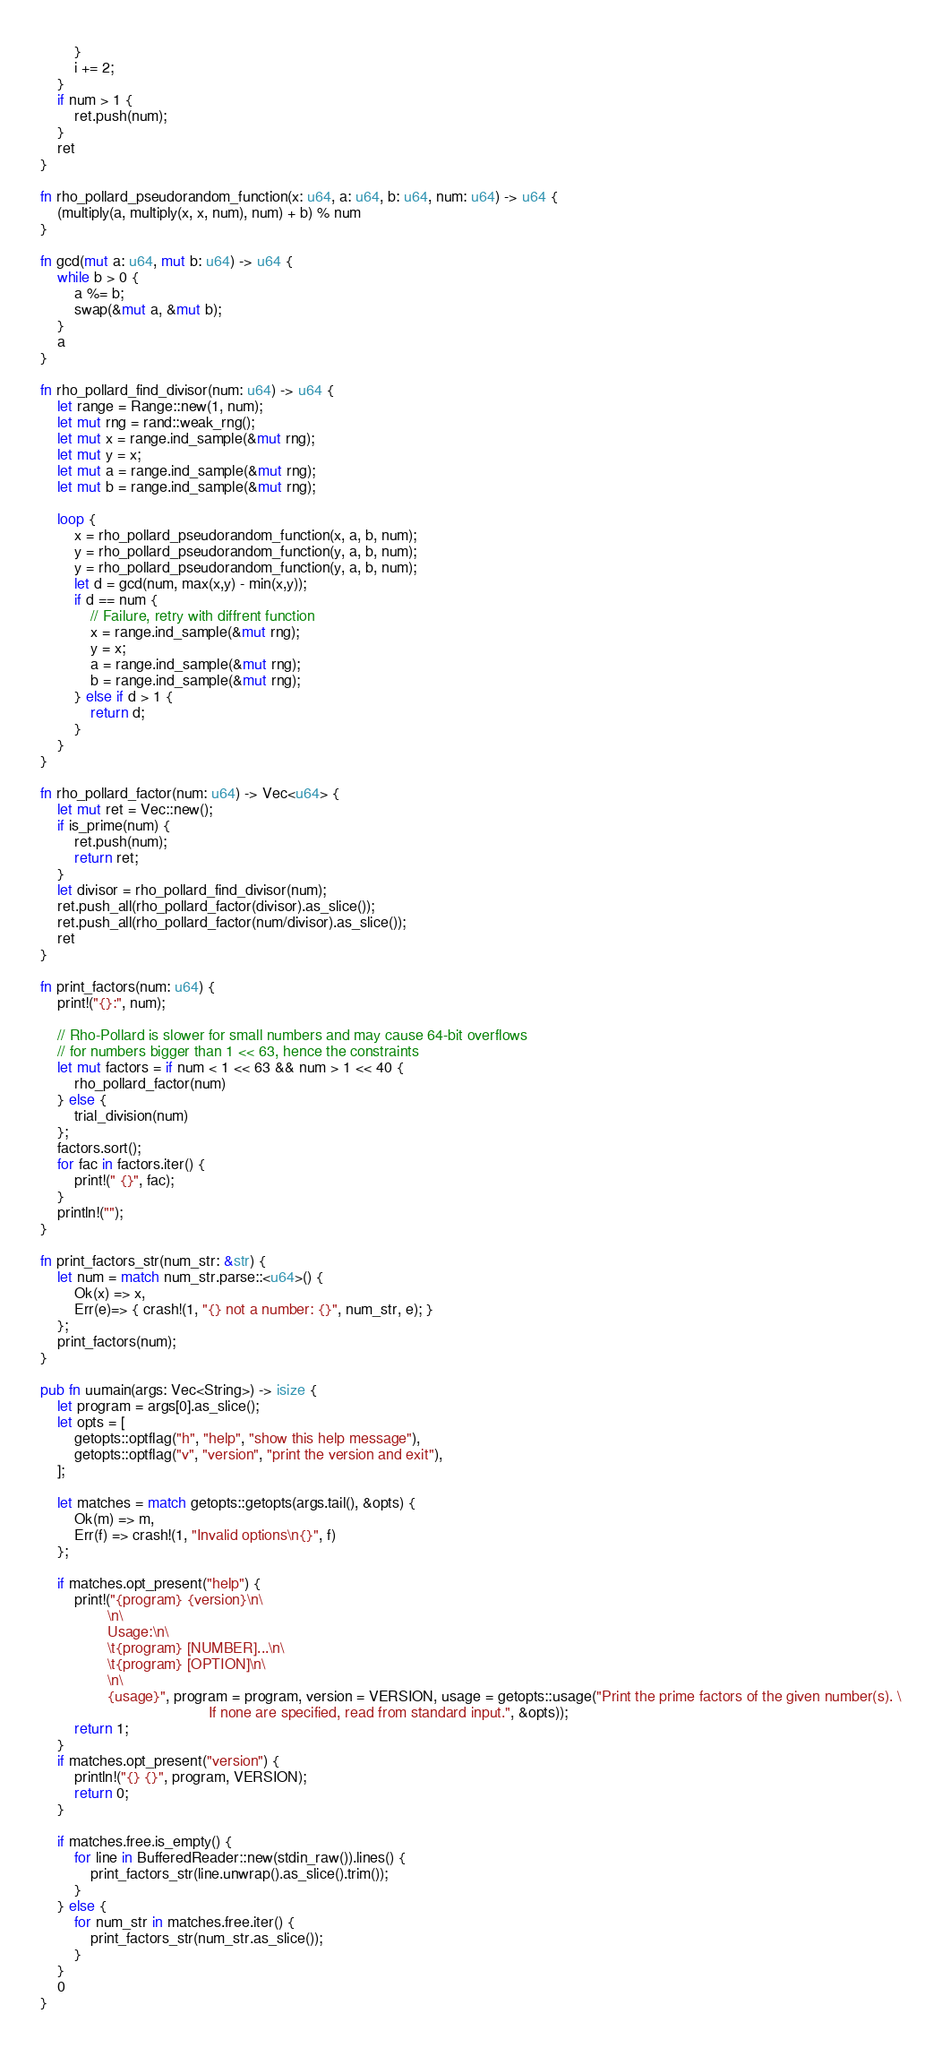<code> <loc_0><loc_0><loc_500><loc_500><_Rust_>        }
        i += 2;
    }
    if num > 1 {
        ret.push(num);
    }
    ret
}

fn rho_pollard_pseudorandom_function(x: u64, a: u64, b: u64, num: u64) -> u64 {
    (multiply(a, multiply(x, x, num), num) + b) % num
}

fn gcd(mut a: u64, mut b: u64) -> u64 {
    while b > 0 {
        a %= b;
        swap(&mut a, &mut b);
    }
    a
}

fn rho_pollard_find_divisor(num: u64) -> u64 {
    let range = Range::new(1, num);
    let mut rng = rand::weak_rng();
    let mut x = range.ind_sample(&mut rng);
    let mut y = x;
    let mut a = range.ind_sample(&mut rng);
    let mut b = range.ind_sample(&mut rng);

    loop {
        x = rho_pollard_pseudorandom_function(x, a, b, num);
        y = rho_pollard_pseudorandom_function(y, a, b, num);
        y = rho_pollard_pseudorandom_function(y, a, b, num);
        let d = gcd(num, max(x,y) - min(x,y));
        if d == num {
            // Failure, retry with diffrent function
            x = range.ind_sample(&mut rng);
            y = x;
            a = range.ind_sample(&mut rng);
            b = range.ind_sample(&mut rng);
        } else if d > 1 {
            return d;
        }
    }
}

fn rho_pollard_factor(num: u64) -> Vec<u64> {
    let mut ret = Vec::new();
    if is_prime(num) {
        ret.push(num);
        return ret;
    }
    let divisor = rho_pollard_find_divisor(num);
    ret.push_all(rho_pollard_factor(divisor).as_slice());
    ret.push_all(rho_pollard_factor(num/divisor).as_slice());
    ret
}

fn print_factors(num: u64) {
    print!("{}:", num);

    // Rho-Pollard is slower for small numbers and may cause 64-bit overflows
    // for numbers bigger than 1 << 63, hence the constraints
    let mut factors = if num < 1 << 63 && num > 1 << 40 {
        rho_pollard_factor(num)
    } else {
        trial_division(num)
    };
    factors.sort();
    for fac in factors.iter() {
        print!(" {}", fac);
    }
    println!("");
}

fn print_factors_str(num_str: &str) {
    let num = match num_str.parse::<u64>() {
        Ok(x) => x,
        Err(e)=> { crash!(1, "{} not a number: {}", num_str, e); }
    };
    print_factors(num);
}

pub fn uumain(args: Vec<String>) -> isize {
    let program = args[0].as_slice();
    let opts = [
        getopts::optflag("h", "help", "show this help message"),
        getopts::optflag("v", "version", "print the version and exit"),
    ];

    let matches = match getopts::getopts(args.tail(), &opts) {
        Ok(m) => m,
        Err(f) => crash!(1, "Invalid options\n{}", f)
    };

    if matches.opt_present("help") {
        print!("{program} {version}\n\
                \n\
                Usage:\n\
                \t{program} [NUMBER]...\n\
                \t{program} [OPTION]\n\
                \n\
                {usage}", program = program, version = VERSION, usage = getopts::usage("Print the prime factors of the given number(s). \
                                        If none are specified, read from standard input.", &opts));
        return 1;
    }
    if matches.opt_present("version") {
        println!("{} {}", program, VERSION);
        return 0;
    }

    if matches.free.is_empty() {
        for line in BufferedReader::new(stdin_raw()).lines() {
            print_factors_str(line.unwrap().as_slice().trim());
        }
    } else {
        for num_str in matches.free.iter() {
            print_factors_str(num_str.as_slice());
        }
    }
    0
}
</code> 